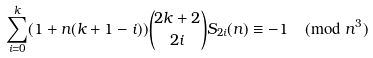Convert formula to latex. <formula><loc_0><loc_0><loc_500><loc_500>\sum _ { i = 0 } ^ { k } ( 1 + n ( k + 1 - i ) ) { 2 k + 2 \choose 2 i } S _ { 2 i } ( n ) \equiv - 1 \pmod { n ^ { 3 } }</formula> 